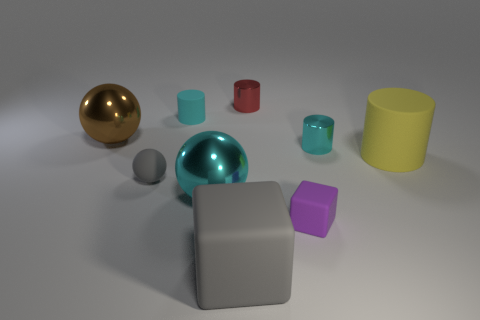There is a large thing that is the same color as the rubber sphere; what is its shape?
Your answer should be very brief. Cube. Is there a big rubber thing that has the same color as the small rubber sphere?
Make the answer very short. Yes. Are there any other things that are the same color as the rubber ball?
Ensure brevity in your answer.  Yes. Are there more large brown objects left of the tiny gray rubber thing than big green matte objects?
Your response must be concise. Yes. There is a big matte thing on the right side of the tiny cube; does it have the same shape as the tiny cyan matte thing?
Make the answer very short. Yes. What number of objects are either gray matte objects or small cyan things right of the small matte cylinder?
Make the answer very short. 3. There is a cyan object that is behind the big yellow rubber thing and left of the large gray block; what size is it?
Your answer should be compact. Small. Are there more tiny cyan cylinders that are to the right of the small matte cylinder than tiny cyan shiny things that are in front of the yellow rubber thing?
Your answer should be compact. Yes. There is a tiny gray thing; is it the same shape as the cyan thing in front of the tiny cyan metallic thing?
Ensure brevity in your answer.  Yes. How many other things are there of the same shape as the cyan rubber thing?
Ensure brevity in your answer.  3. 